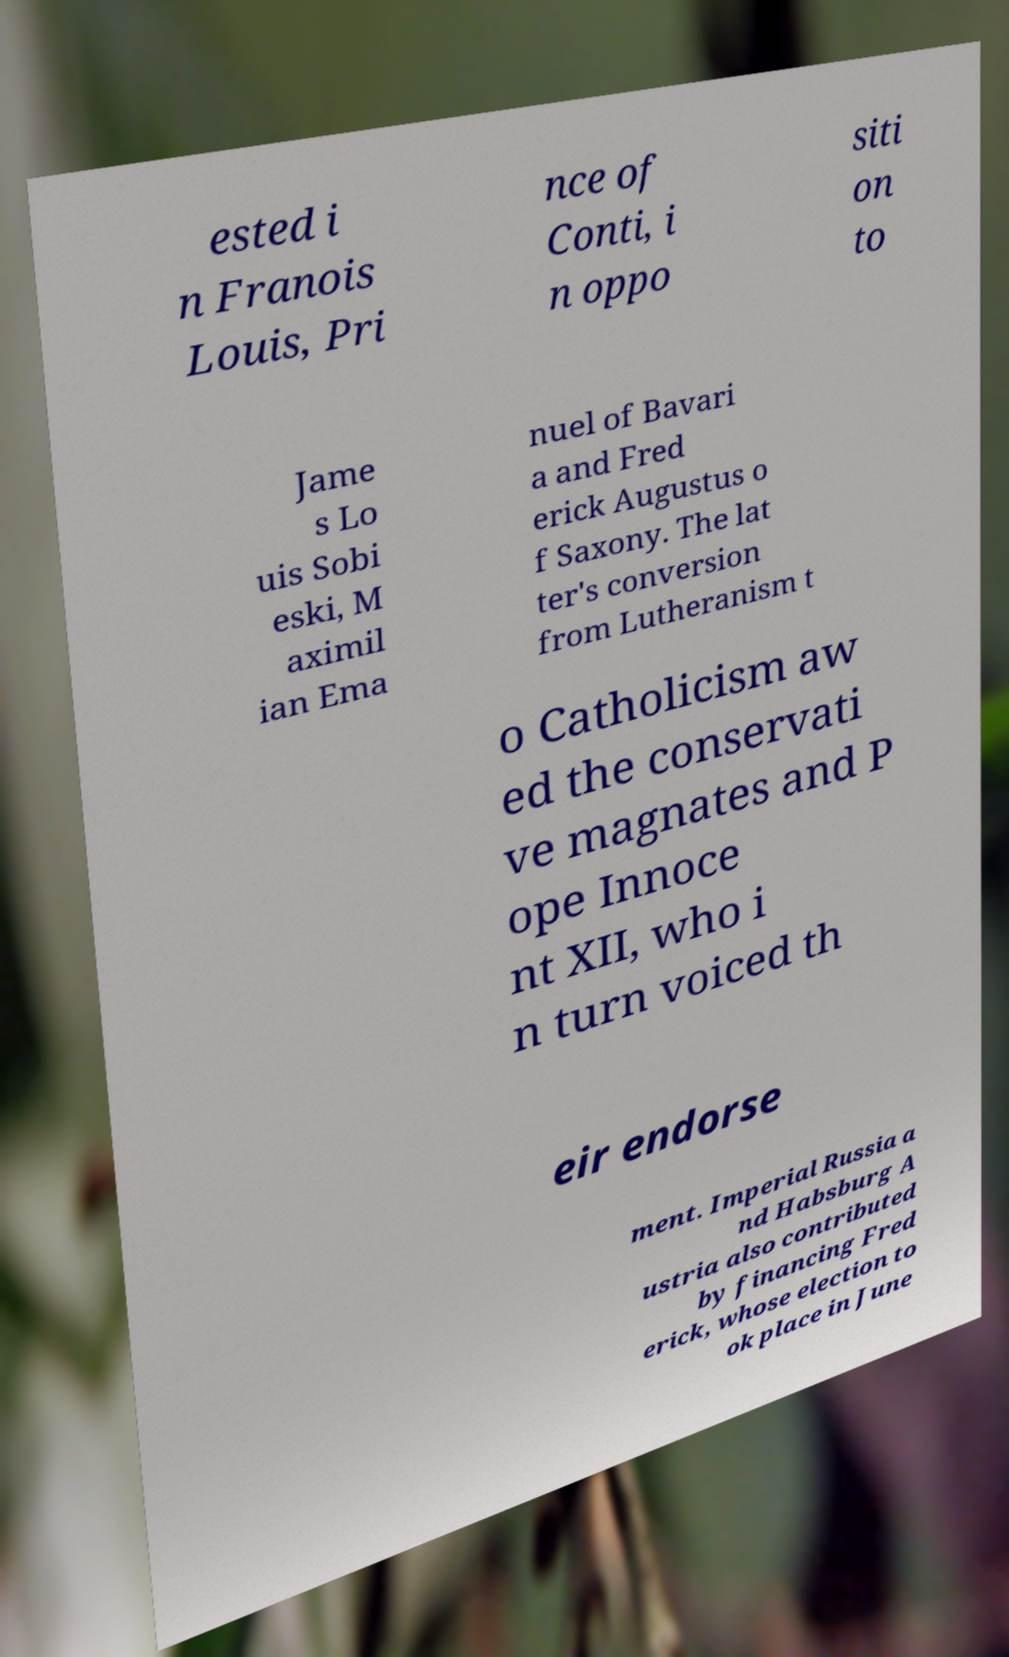Could you assist in decoding the text presented in this image and type it out clearly? ested i n Franois Louis, Pri nce of Conti, i n oppo siti on to Jame s Lo uis Sobi eski, M aximil ian Ema nuel of Bavari a and Fred erick Augustus o f Saxony. The lat ter's conversion from Lutheranism t o Catholicism aw ed the conservati ve magnates and P ope Innoce nt XII, who i n turn voiced th eir endorse ment. Imperial Russia a nd Habsburg A ustria also contributed by financing Fred erick, whose election to ok place in June 